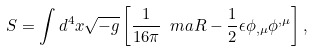Convert formula to latex. <formula><loc_0><loc_0><loc_500><loc_500>S = \int d ^ { 4 } x \sqrt { - g } \left [ \frac { 1 } { 1 6 \pi } { \ m a R } - \frac { 1 } { 2 } \epsilon \phi _ { , \mu } \phi ^ { , \mu } \right ] ,</formula> 